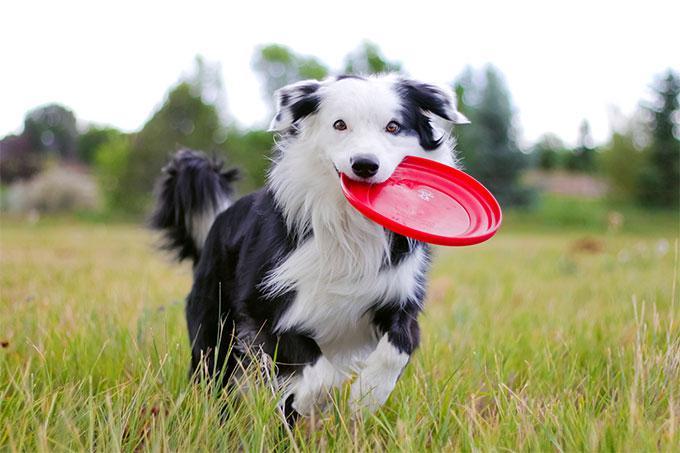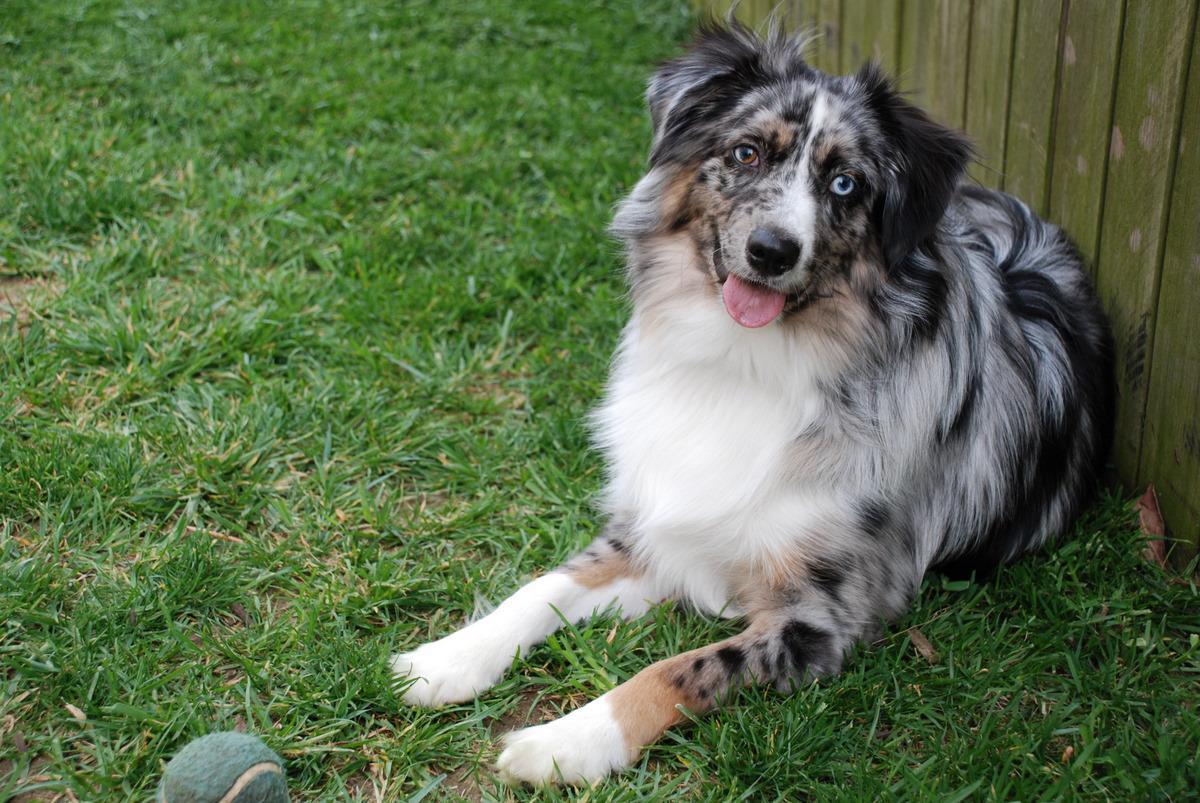The first image is the image on the left, the second image is the image on the right. Examine the images to the left and right. Is the description "An image shows one dog posed in the grass with a yellow ball." accurate? Answer yes or no. No. The first image is the image on the left, the second image is the image on the right. For the images displayed, is the sentence "The left image shows a dog running through grass while holding a toy in its mouth" factually correct? Answer yes or no. Yes. 